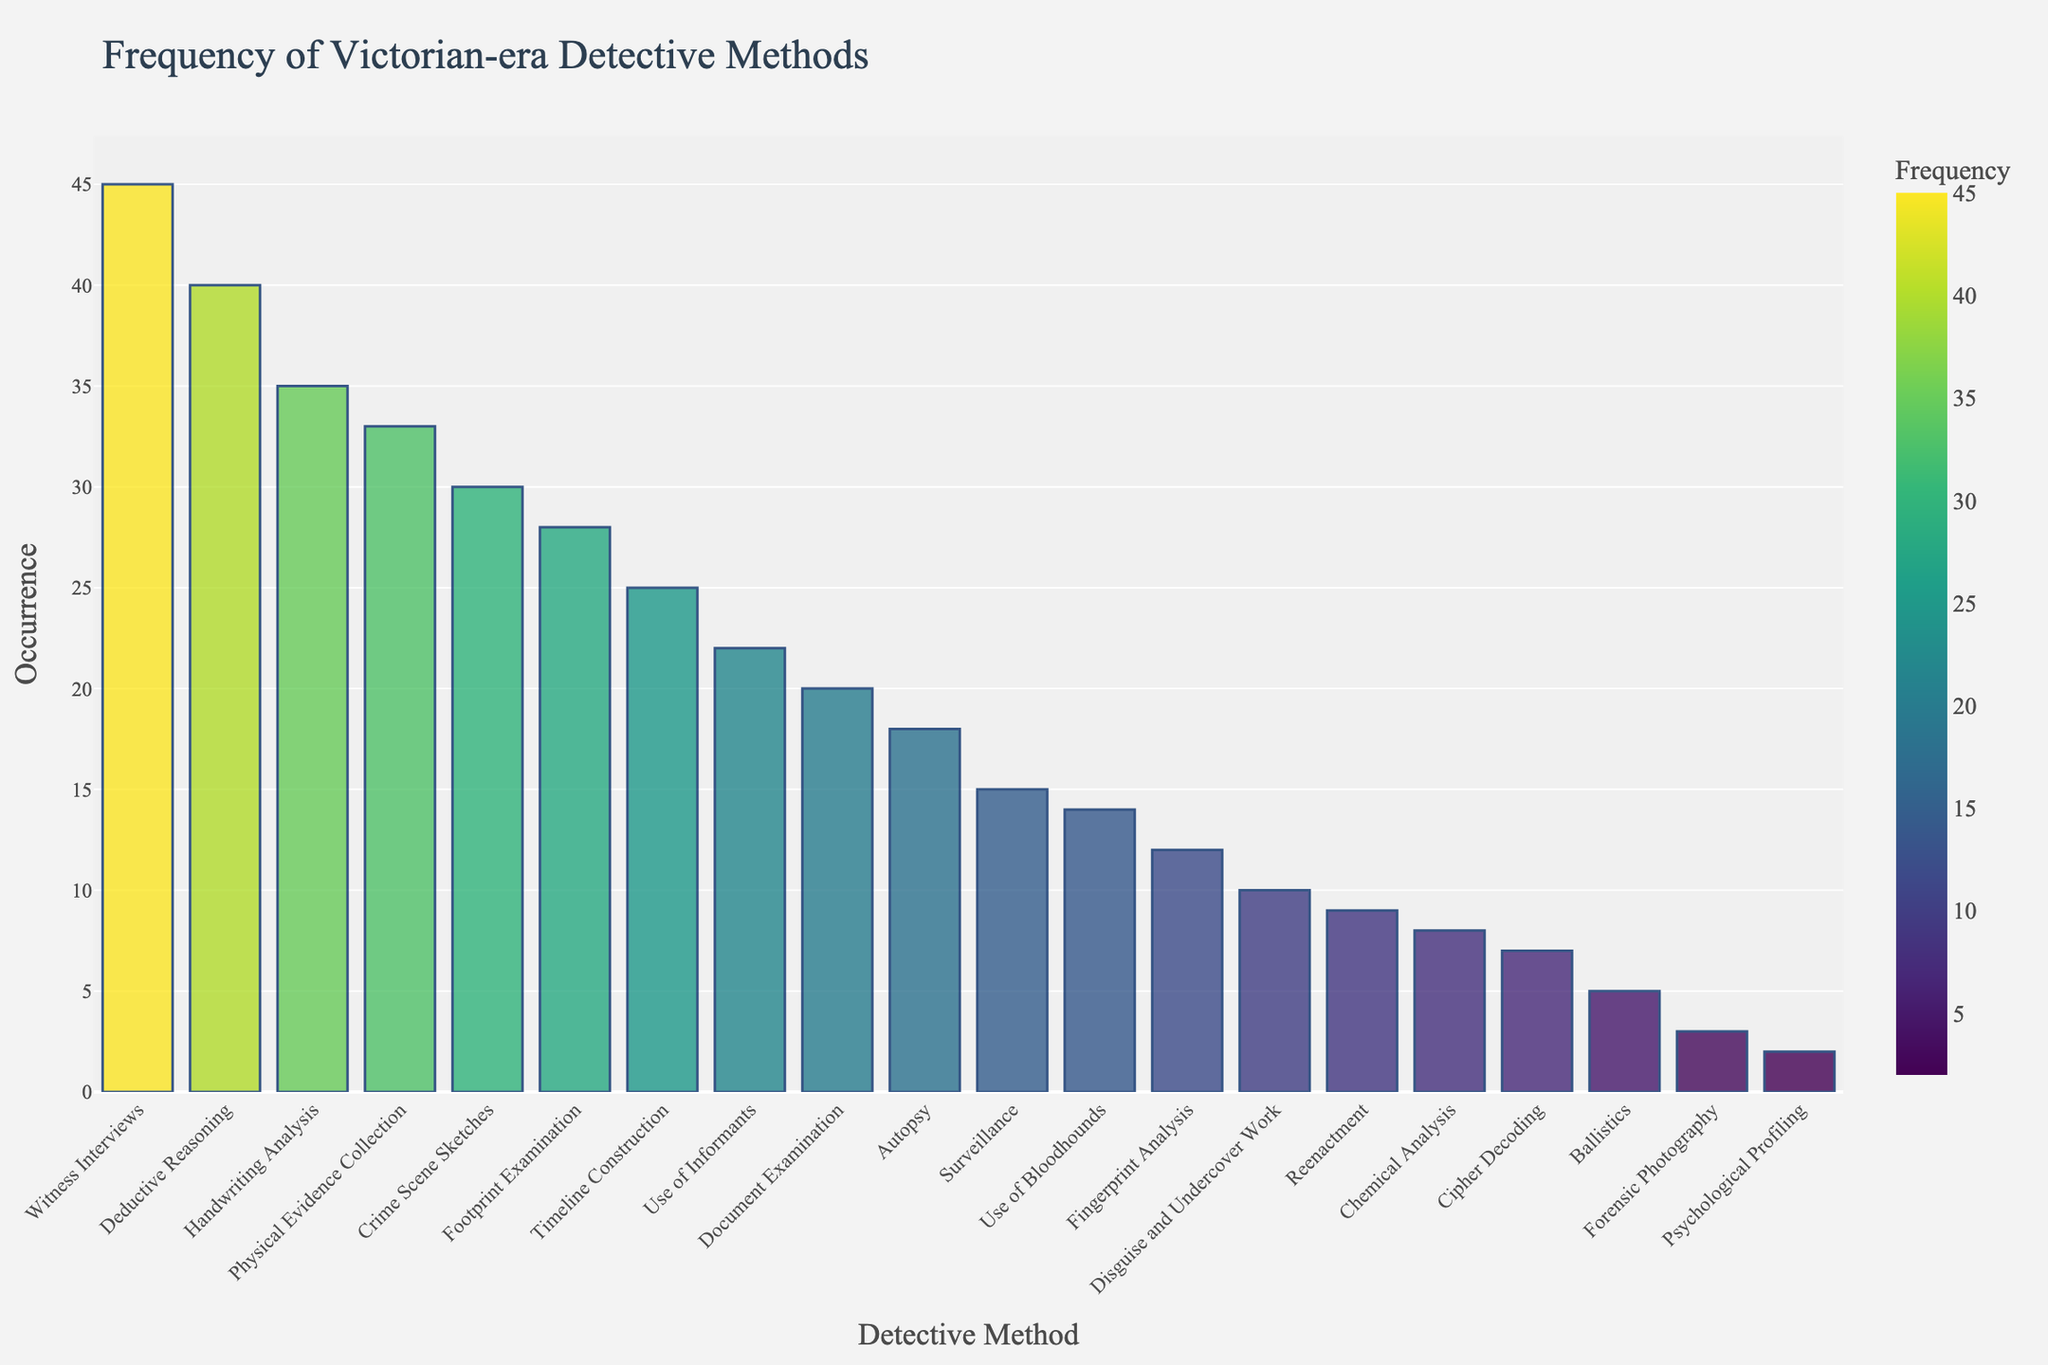What's the most frequently used detective method? The tallest bar on the chart corresponds to the most frequently used method, which is Witness Interviews with a frequency of 45.
Answer: Witness Interviews Which method is used less frequently than Footprint Examination but more frequently than Use of Informants? The method Footprint Examination has a frequency of 28, and Use of Informants has a frequency of 22. The method with a frequency between these two is Crime Scene Sketches with a frequency of 30.
Answer: Crime Scene Sketches How many methods have a frequency higher than 20? Count the number of methods with frequency values higher than 20: Footprint Examination (28), Handwriting Analysis (35), Witness Interviews (45), Crime Scene Sketches (30), Deductive Reasoning (40), Use of Informants (22), Timeline Construction (25), Document Examination (20, but not higher). There are 7 methods with a frequency higher than 20.
Answer: 7 Which method has the least frequency, and what is its value? The shortest bar on the chart indicates the least frequently used method, which is Psychological Profiling with a frequency of 2.
Answer: Psychological Profiling, 2 What is the difference in frequency between Deductive Reasoning and Forensic Photography? Deductive Reasoning has a frequency of 40, and Forensic Photography has a frequency of 3. The difference is 40 - 3 = 37.
Answer: 37 What's the total frequency of the top three most used methods? The top three most used methods are Witness Interviews (45), Deductive Reasoning (40), and Handwriting Analysis (35). The total is 45 + 40 + 35 = 120.
Answer: 120 Which methods have a frequency equal to or lower than 10? The methods with frequencies equal to or lower than 10 are Chemical Analysis (8), Ballistics (5), Disguise and Undercover Work (10), Forensic Photography (3), Cipher Decoding (7), Psychological Profiling (2), Reenactment (9).
Answer: 7 methods (Chemical Analysis, Ballistics, Disguise and Undercover Work, Forensic Photography, Cipher Decoding, Psychological Profiling, Reenactment) How does the frequency of Footprint Examination compare to Autopsy? The frequency of Footprint Examination is 28, while the frequency of Autopsy is 18. Since 28 is greater than 18, Footprint Examination is used more frequently than Autopsy.
Answer: Footprint Examination is more frequent What is the average frequency of the top five most used methods? The top five most used methods are Witness Interviews (45), Deductive Reasoning (40), Handwriting Analysis (35), Crime Scene Sketches (30), Footprint Examination (28). The sum is 45 + 40 + 35 + 30 + 28 = 178. The average is 178 / 5 = 35.6.
Answer: 35.6 